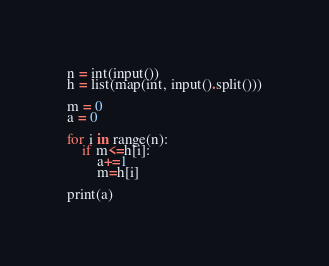Convert code to text. <code><loc_0><loc_0><loc_500><loc_500><_Python_>n = int(input())
h = list(map(int, input().split()))

m = 0
a = 0

for i in range(n):
    if m<=h[i]:
        a+=1
        m=h[i]

print(a)</code> 